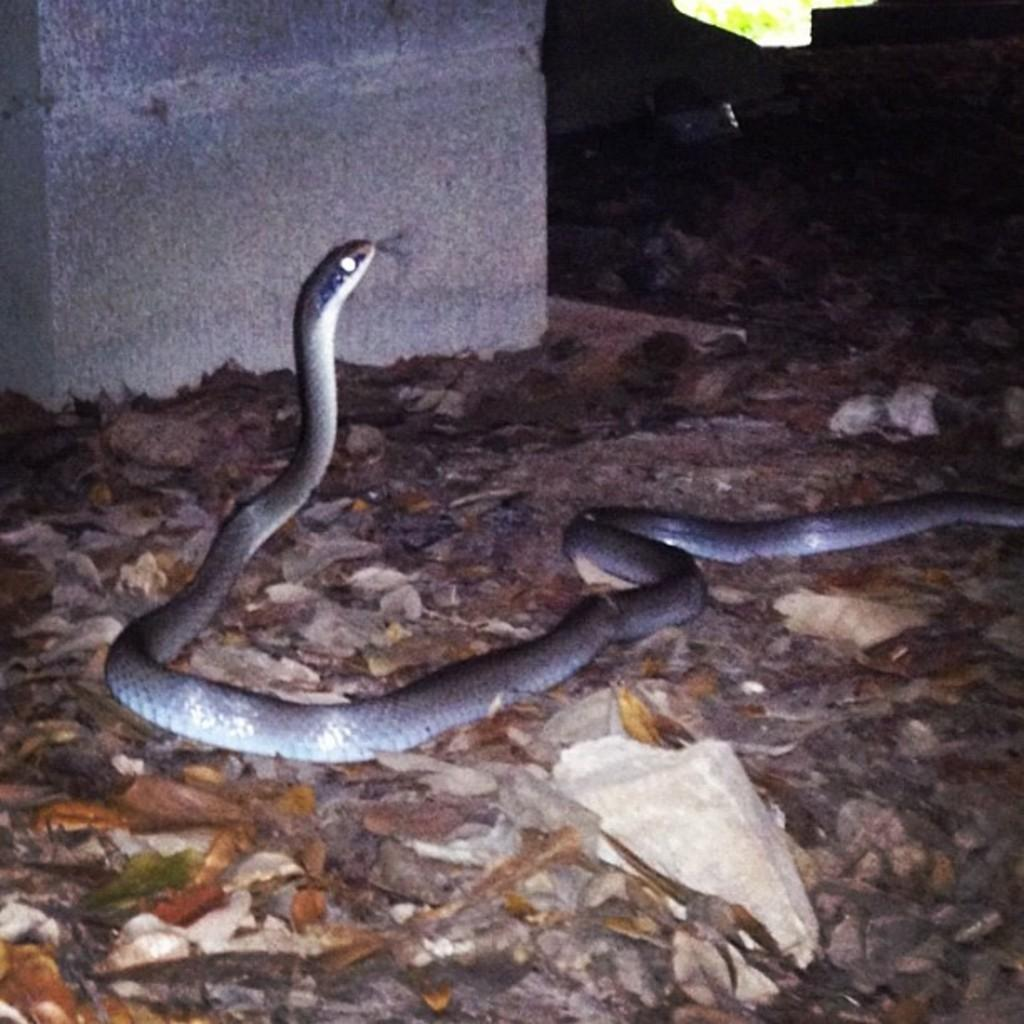What type of animal is in the image? There is a snake in the image. What can be seen on the ground in the image? There are leaves on the ground in the image. What is visible in the background of the image? There is a wall visible in the background of the image. What channel is the grandmother watching in the image? There is no mention of a grandmother or a channel in the image, as it only features a snake and leaves on the ground with a wall in the background. 